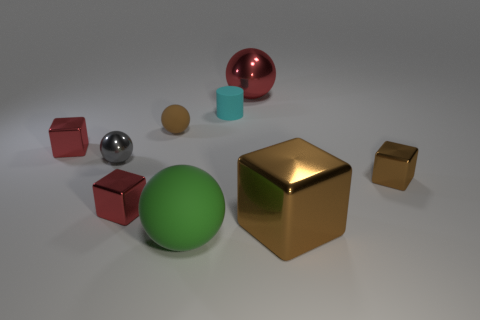How many small metal objects are right of the gray metallic ball and left of the big brown thing?
Make the answer very short. 1. What shape is the tiny rubber object on the right side of the big green object?
Offer a very short reply. Cylinder. What number of brown balls are the same size as the cylinder?
Provide a short and direct response. 1. There is a metal sphere to the left of the brown rubber sphere; does it have the same color as the cylinder?
Provide a short and direct response. No. There is a large thing that is both on the right side of the cyan object and in front of the small brown matte ball; what material is it?
Offer a terse response. Metal. Are there more big red metal cylinders than brown spheres?
Offer a terse response. No. What is the color of the big shiny object that is behind the tiny cube that is right of the small sphere behind the gray sphere?
Make the answer very short. Red. Is the material of the sphere on the right side of the green thing the same as the large green ball?
Provide a short and direct response. No. Are there any big cubes that have the same color as the small rubber sphere?
Provide a succinct answer. Yes. Are there any large brown shiny objects?
Provide a short and direct response. Yes. 